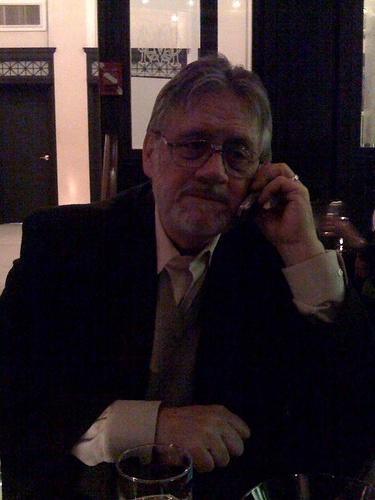Describe the objects in this image and their specific colors. I can see people in black, ivory, maroon, and gray tones, cup in ivory, black, and gray tones, and cell phone in ivory, black, brown, and purple tones in this image. 